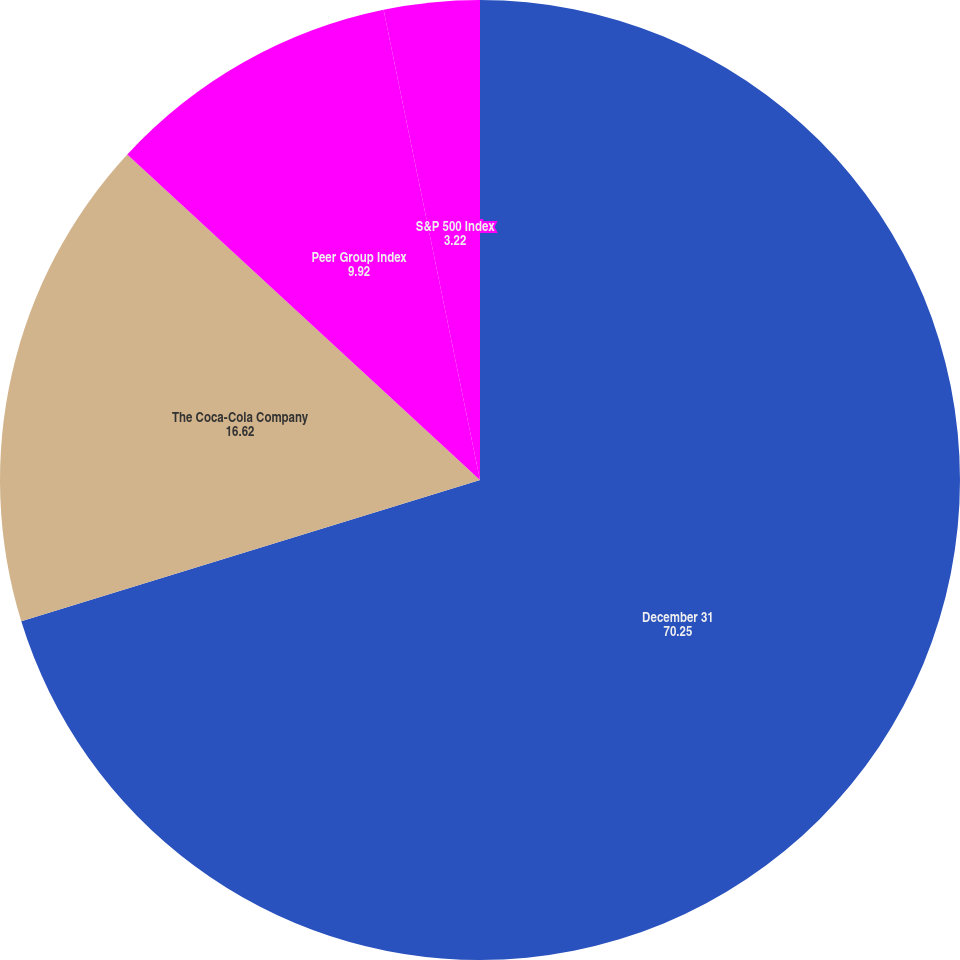Convert chart. <chart><loc_0><loc_0><loc_500><loc_500><pie_chart><fcel>December 31<fcel>The Coca-Cola Company<fcel>Peer Group Index<fcel>S&P 500 Index<nl><fcel>70.25%<fcel>16.62%<fcel>9.92%<fcel>3.22%<nl></chart> 